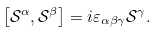<formula> <loc_0><loc_0><loc_500><loc_500>\left [ \mathcal { S } ^ { \alpha } , \mathcal { S } ^ { \beta } \right ] = i \varepsilon _ { \alpha \beta \gamma } \mathcal { S } ^ { \gamma } .</formula> 